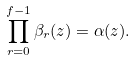<formula> <loc_0><loc_0><loc_500><loc_500>\prod _ { r = 0 } ^ { f - 1 } \beta _ { r } ( z ) = \alpha ( z ) .</formula> 